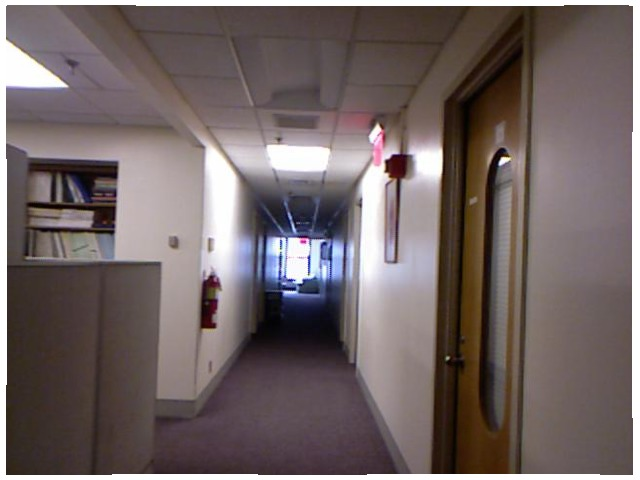<image>
Can you confirm if the fire extinguisher is under the switch? Yes. The fire extinguisher is positioned underneath the switch, with the switch above it in the vertical space. Is the fire extinguisher on the wall? Yes. Looking at the image, I can see the fire extinguisher is positioned on top of the wall, with the wall providing support. 